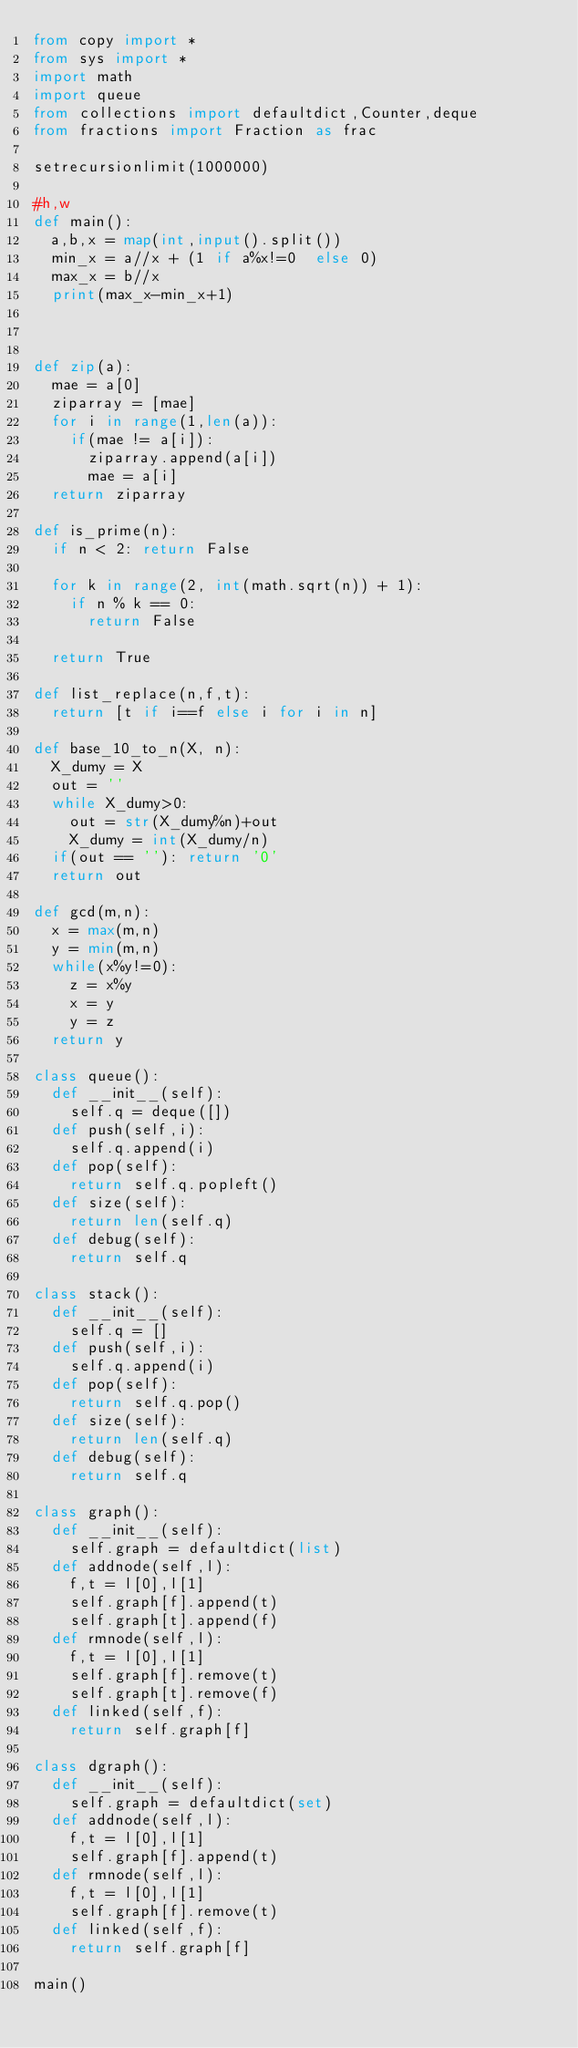<code> <loc_0><loc_0><loc_500><loc_500><_Python_>from copy import *
from sys import *
import math
import queue
from collections import defaultdict,Counter,deque
from fractions import Fraction as frac

setrecursionlimit(1000000)

#h,w
def main():
	a,b,x = map(int,input().split())
	min_x = a//x + (1 if a%x!=0  else 0)
	max_x = b//x 
	print(max_x-min_x+1)



def zip(a):
	mae = a[0]
	ziparray = [mae]
	for i in range(1,len(a)):
		if(mae != a[i]):
			ziparray.append(a[i])
			mae = a[i]
	return ziparray

def is_prime(n):
	if n < 2: return False

	for k in range(2, int(math.sqrt(n)) + 1):
		if n % k == 0:
			return False

	return True

def list_replace(n,f,t):
	return [t if i==f else i for i in n]

def base_10_to_n(X, n):
	X_dumy = X
	out = ''
	while X_dumy>0:
		out = str(X_dumy%n)+out
		X_dumy = int(X_dumy/n)
	if(out == ''): return '0'
	return out

def gcd(m,n):
	x = max(m,n)
	y = min(m,n)
	while(x%y!=0):
		z = x%y
		x = y
		y = z
	return y

class queue():
	def __init__(self):
		self.q = deque([])
	def push(self,i):
		self.q.append(i)
	def pop(self):
		return self.q.popleft()
	def size(self):
		return len(self.q)
	def debug(self):
		return self.q

class stack():
	def __init__(self):
		self.q = []
	def push(self,i):
		self.q.append(i)
	def pop(self):
		return self.q.pop()
	def size(self):
		return len(self.q)
	def debug(self):
		return self.q

class graph():
	def __init__(self):
		self.graph = defaultdict(list)
	def addnode(self,l):
		f,t = l[0],l[1]
		self.graph[f].append(t)
		self.graph[t].append(f)
	def rmnode(self,l):
		f,t = l[0],l[1]
		self.graph[f].remove(t)
		self.graph[t].remove(f)
	def linked(self,f):
		return self.graph[f]

class dgraph():
	def __init__(self):
		self.graph = defaultdict(set)
	def addnode(self,l):
		f,t = l[0],l[1]
		self.graph[f].append(t)
	def rmnode(self,l):
		f,t = l[0],l[1]
		self.graph[f].remove(t)
	def linked(self,f):
		return self.graph[f]

main()</code> 